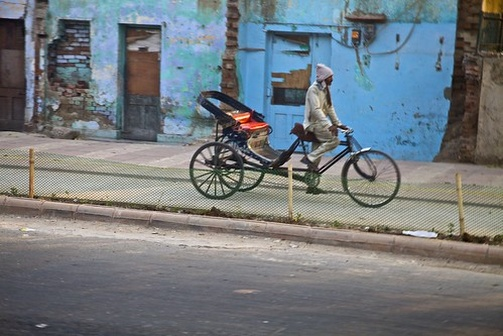Imagine if the tricycle could talk. What stories would it share about its journeys? If the tricycle could talk, it might say: 'Oh, the tales I could tell! I’ve ventured through the bustling markets, carrying fresh produce and handmade crafts. I've rolled down quiet alleys where children chase each other in play. Sometimes, I’m loaded with flowers for a celebration, other times, with tools for hardworking hands. I've seen seasons change and watched the city transform, carrying stories of every rider and every street I’ve traversed.' 